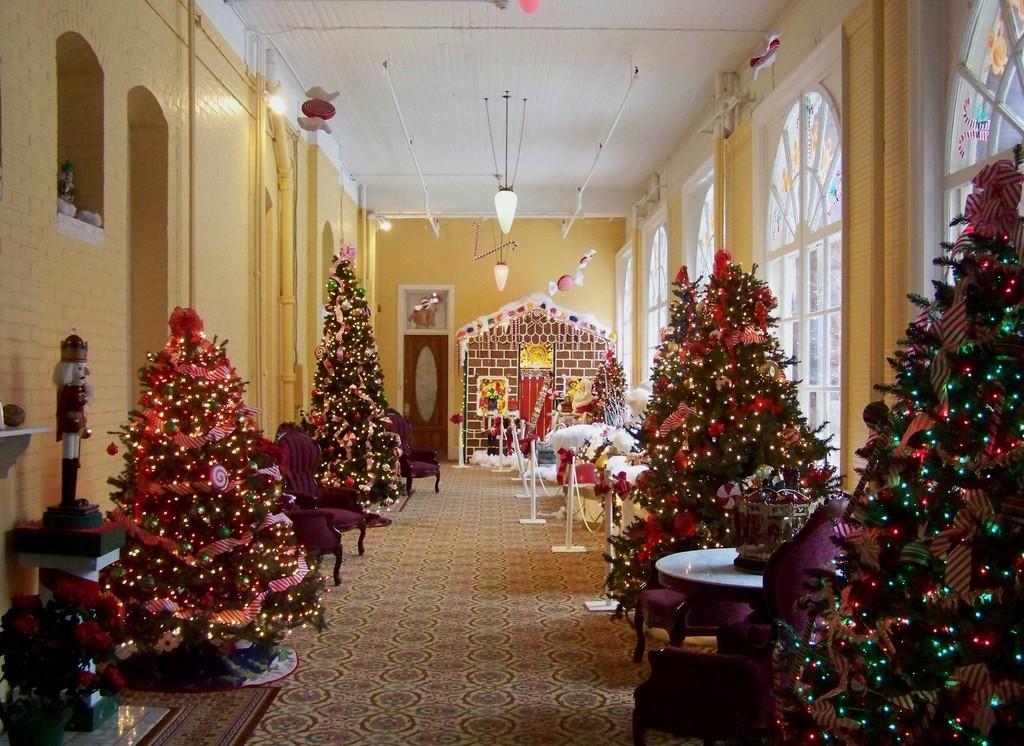Please provide a concise description of this image. In this picture there are some trees decorated with lights and in between there are tables and a railing here. In the background there is a wall and some ceiling lights here. 